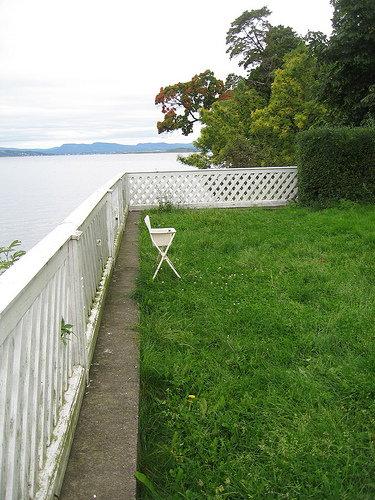<image>
Can you confirm if the stand is on the grass? Yes. Looking at the image, I can see the stand is positioned on top of the grass, with the grass providing support. Where is the mountains in relation to the chair? Is it on the chair? No. The mountains is not positioned on the chair. They may be near each other, but the mountains is not supported by or resting on top of the chair. Is the chair next to the lawn? No. The chair is not positioned next to the lawn. They are located in different areas of the scene. 